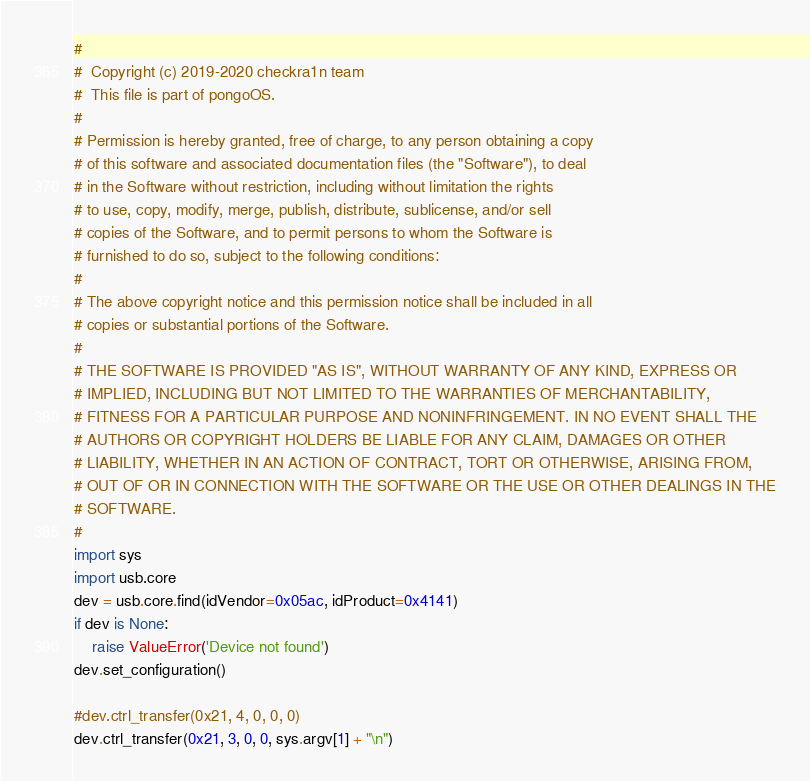<code> <loc_0><loc_0><loc_500><loc_500><_Python_>#
#  Copyright (c) 2019-2020 checkra1n team
#  This file is part of pongoOS.
#
# Permission is hereby granted, free of charge, to any person obtaining a copy
# of this software and associated documentation files (the "Software"), to deal
# in the Software without restriction, including without limitation the rights
# to use, copy, modify, merge, publish, distribute, sublicense, and/or sell
# copies of the Software, and to permit persons to whom the Software is
# furnished to do so, subject to the following conditions:
#
# The above copyright notice and this permission notice shall be included in all
# copies or substantial portions of the Software.
#
# THE SOFTWARE IS PROVIDED "AS IS", WITHOUT WARRANTY OF ANY KIND, EXPRESS OR
# IMPLIED, INCLUDING BUT NOT LIMITED TO THE WARRANTIES OF MERCHANTABILITY,
# FITNESS FOR A PARTICULAR PURPOSE AND NONINFRINGEMENT. IN NO EVENT SHALL THE
# AUTHORS OR COPYRIGHT HOLDERS BE LIABLE FOR ANY CLAIM, DAMAGES OR OTHER
# LIABILITY, WHETHER IN AN ACTION OF CONTRACT, TORT OR OTHERWISE, ARISING FROM,
# OUT OF OR IN CONNECTION WITH THE SOFTWARE OR THE USE OR OTHER DEALINGS IN THE
# SOFTWARE.
# 
import sys
import usb.core
dev = usb.core.find(idVendor=0x05ac, idProduct=0x4141)
if dev is None:
    raise ValueError('Device not found')
dev.set_configuration()

#dev.ctrl_transfer(0x21, 4, 0, 0, 0)
dev.ctrl_transfer(0x21, 3, 0, 0, sys.argv[1] + "\n")
</code> 